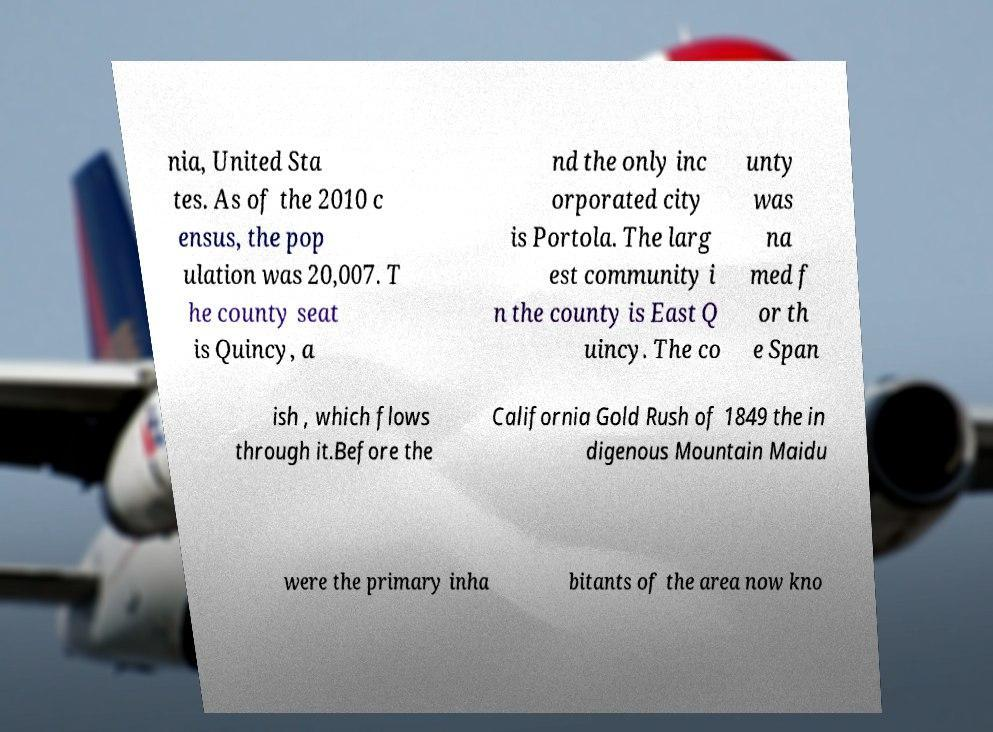For documentation purposes, I need the text within this image transcribed. Could you provide that? nia, United Sta tes. As of the 2010 c ensus, the pop ulation was 20,007. T he county seat is Quincy, a nd the only inc orporated city is Portola. The larg est community i n the county is East Q uincy. The co unty was na med f or th e Span ish , which flows through it.Before the California Gold Rush of 1849 the in digenous Mountain Maidu were the primary inha bitants of the area now kno 